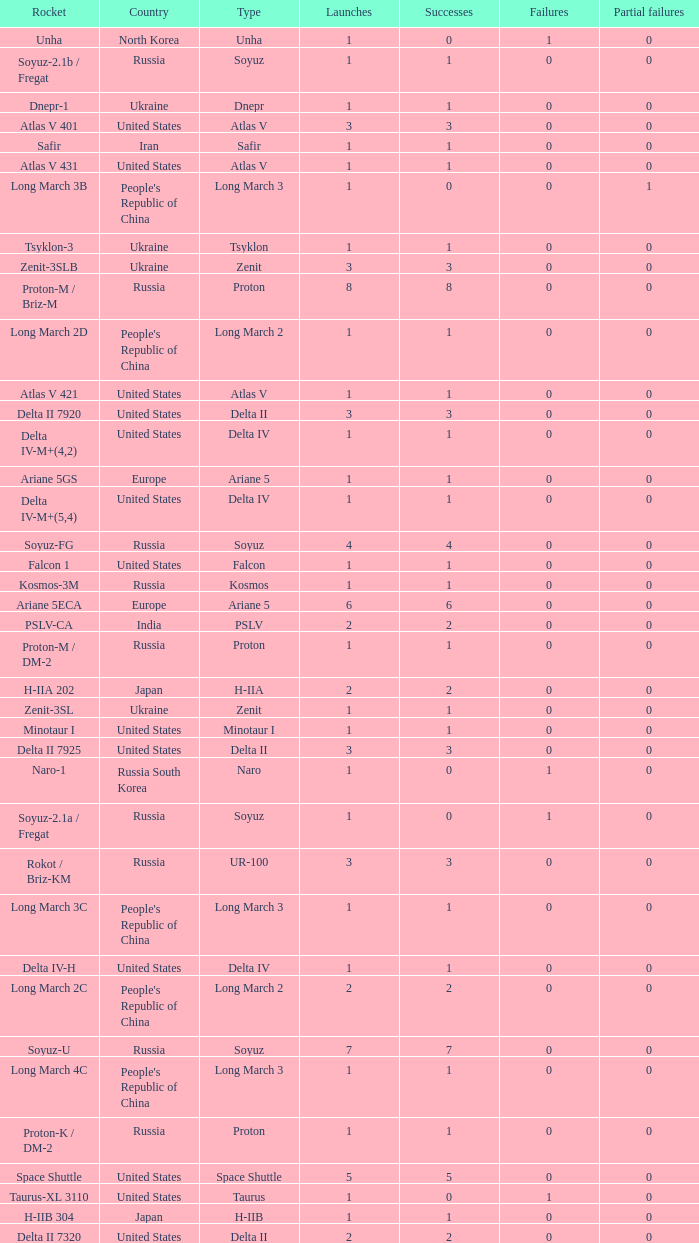What is the number of successes for rockets that have more than 3 launches, were based in Russia, are type soyuz and a rocket type of soyuz-u? 1.0. 